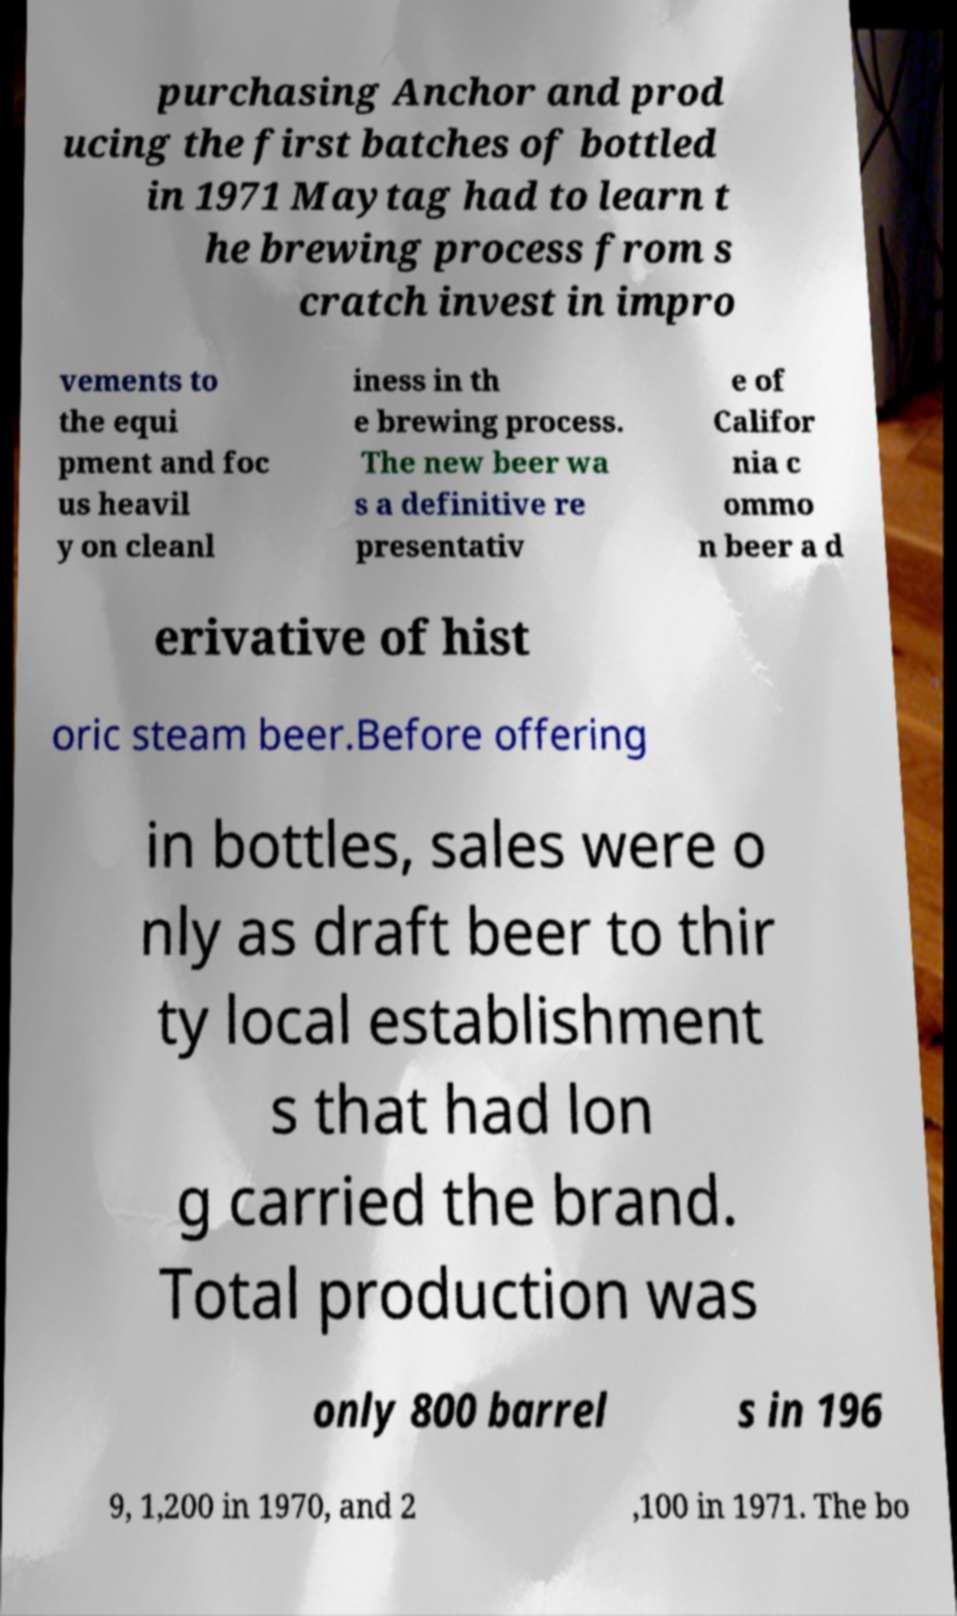There's text embedded in this image that I need extracted. Can you transcribe it verbatim? purchasing Anchor and prod ucing the first batches of bottled in 1971 Maytag had to learn t he brewing process from s cratch invest in impro vements to the equi pment and foc us heavil y on cleanl iness in th e brewing process. The new beer wa s a definitive re presentativ e of Califor nia c ommo n beer a d erivative of hist oric steam beer.Before offering in bottles, sales were o nly as draft beer to thir ty local establishment s that had lon g carried the brand. Total production was only 800 barrel s in 196 9, 1,200 in 1970, and 2 ,100 in 1971. The bo 